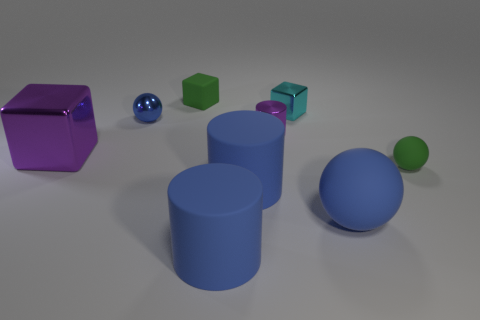Subtract all small blue balls. How many balls are left? 2 Subtract all yellow balls. How many blue cylinders are left? 2 Subtract 1 balls. How many balls are left? 2 Subtract all balls. How many objects are left? 6 Subtract all red blocks. Subtract all blue spheres. How many blocks are left? 3 Subtract 0 brown spheres. How many objects are left? 9 Subtract all purple metal blocks. Subtract all big blue balls. How many objects are left? 7 Add 6 large blue matte things. How many large blue matte things are left? 9 Add 5 big cyan matte blocks. How many big cyan matte blocks exist? 5 